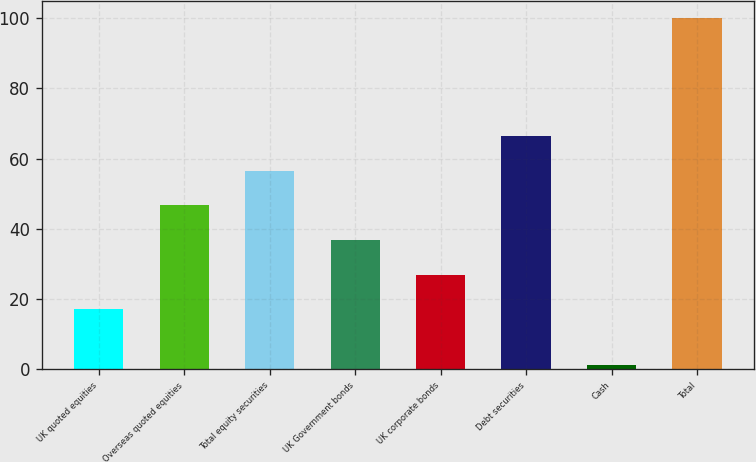Convert chart. <chart><loc_0><loc_0><loc_500><loc_500><bar_chart><fcel>UK quoted equities<fcel>Overseas quoted equities<fcel>Total equity securities<fcel>UK Government bonds<fcel>UK corporate bonds<fcel>Debt securities<fcel>Cash<fcel>Total<nl><fcel>17<fcel>46.67<fcel>56.56<fcel>36.78<fcel>26.89<fcel>66.45<fcel>1.08<fcel>100<nl></chart> 